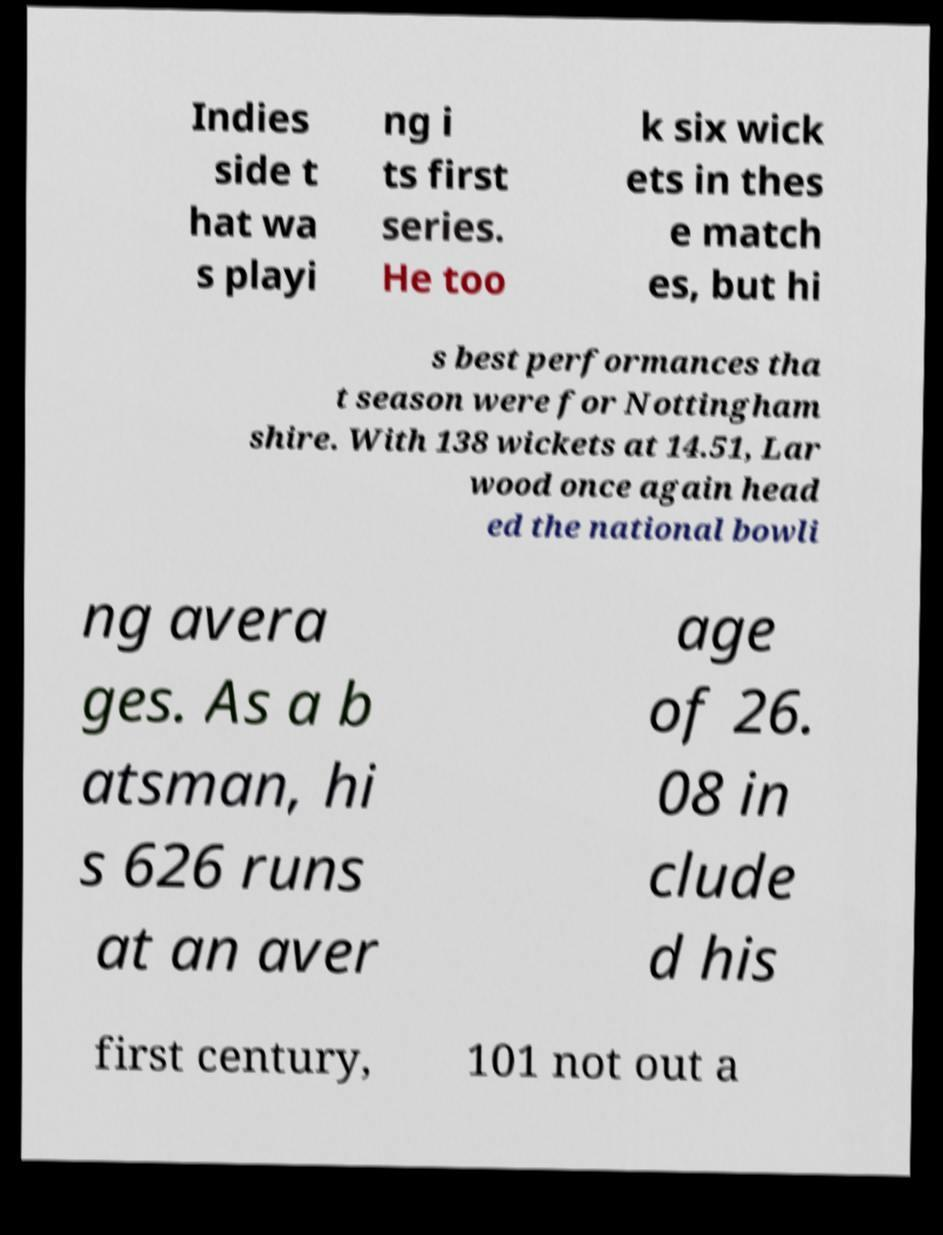Could you assist in decoding the text presented in this image and type it out clearly? Indies side t hat wa s playi ng i ts first series. He too k six wick ets in thes e match es, but hi s best performances tha t season were for Nottingham shire. With 138 wickets at 14.51, Lar wood once again head ed the national bowli ng avera ges. As a b atsman, hi s 626 runs at an aver age of 26. 08 in clude d his first century, 101 not out a 